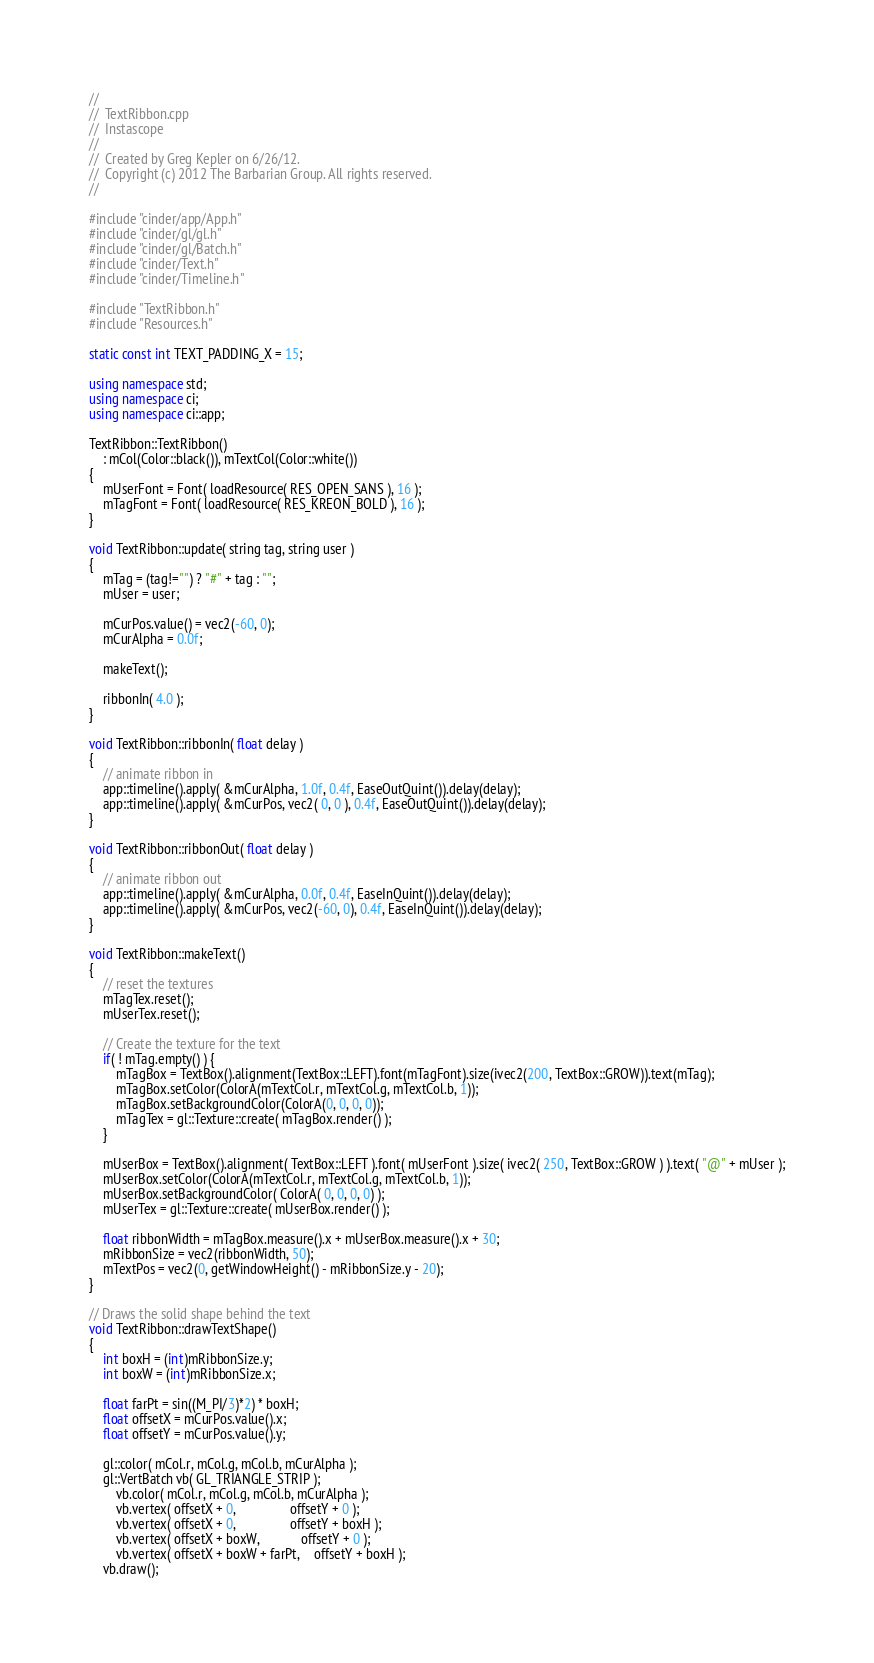<code> <loc_0><loc_0><loc_500><loc_500><_C++_>//
//	TextRibbon.cpp
//	Instascope
//
//	Created by Greg Kepler on 6/26/12.
//	Copyright (c) 2012 The Barbarian Group. All rights reserved.
//

#include "cinder/app/App.h"
#include "cinder/gl/gl.h"
#include "cinder/gl/Batch.h"
#include "cinder/Text.h"
#include "cinder/Timeline.h"

#include "TextRibbon.h"
#include "Resources.h"

static const int TEXT_PADDING_X = 15;

using namespace std;
using namespace ci;
using namespace ci::app;

TextRibbon::TextRibbon()
	: mCol(Color::black()), mTextCol(Color::white())
{
	mUserFont = Font( loadResource( RES_OPEN_SANS ), 16 );
	mTagFont = Font( loadResource( RES_KREON_BOLD ), 16 );
}

void TextRibbon::update( string tag, string user )
{
	mTag = (tag!="") ? "#" + tag : "";
	mUser = user;
	
	mCurPos.value() = vec2(-60, 0);
	mCurAlpha = 0.0f;
	
	makeText();
	
	ribbonIn( 4.0 );
}

void TextRibbon::ribbonIn( float delay )
{
	// animate ribbon in
	app::timeline().apply( &mCurAlpha, 1.0f, 0.4f, EaseOutQuint()).delay(delay);
	app::timeline().apply( &mCurPos, vec2( 0, 0 ), 0.4f, EaseOutQuint()).delay(delay);	
}

void TextRibbon::ribbonOut( float delay )
{
	// animate ribbon out
	app::timeline().apply( &mCurAlpha, 0.0f, 0.4f, EaseInQuint()).delay(delay);
	app::timeline().apply( &mCurPos, vec2(-60, 0), 0.4f, EaseInQuint()).delay(delay);
}

void TextRibbon::makeText()
{
	// reset the textures
	mTagTex.reset();
	mUserTex.reset();
	
	// Create the texture for the text
	if( ! mTag.empty() ) {
		mTagBox = TextBox().alignment(TextBox::LEFT).font(mTagFont).size(ivec2(200, TextBox::GROW)).text(mTag);
		mTagBox.setColor(ColorA(mTextCol.r, mTextCol.g, mTextCol.b, 1));
		mTagBox.setBackgroundColor(ColorA(0, 0, 0, 0));
		mTagTex = gl::Texture::create( mTagBox.render() );
	}
	
	mUserBox = TextBox().alignment( TextBox::LEFT ).font( mUserFont ).size( ivec2( 250, TextBox::GROW ) ).text( "@" + mUser );
	mUserBox.setColor(ColorA(mTextCol.r, mTextCol.g, mTextCol.b, 1));
	mUserBox.setBackgroundColor( ColorA( 0, 0, 0, 0) );
	mUserTex = gl::Texture::create( mUserBox.render() );
	
	float ribbonWidth = mTagBox.measure().x + mUserBox.measure().x + 30;
	mRibbonSize = vec2(ribbonWidth, 50);
	mTextPos = vec2(0, getWindowHeight() - mRibbonSize.y - 20);
}

// Draws the solid shape behind the text
void TextRibbon::drawTextShape()
{
	int boxH = (int)mRibbonSize.y;
	int boxW = (int)mRibbonSize.x;
	
	float farPt = sin((M_PI/3)*2) * boxH;
	float offsetX = mCurPos.value().x;
	float offsetY = mCurPos.value().y;
	
	gl::color( mCol.r, mCol.g, mCol.b, mCurAlpha );
	gl::VertBatch vb( GL_TRIANGLE_STRIP );
		vb.color( mCol.r, mCol.g, mCol.b, mCurAlpha );
		vb.vertex( offsetX + 0,				offsetY + 0 );
		vb.vertex( offsetX + 0,				offsetY + boxH );
		vb.vertex( offsetX + boxW,			offsetY + 0 );
		vb.vertex( offsetX + boxW + farPt,	offsetY + boxH );
	vb.draw();</code> 